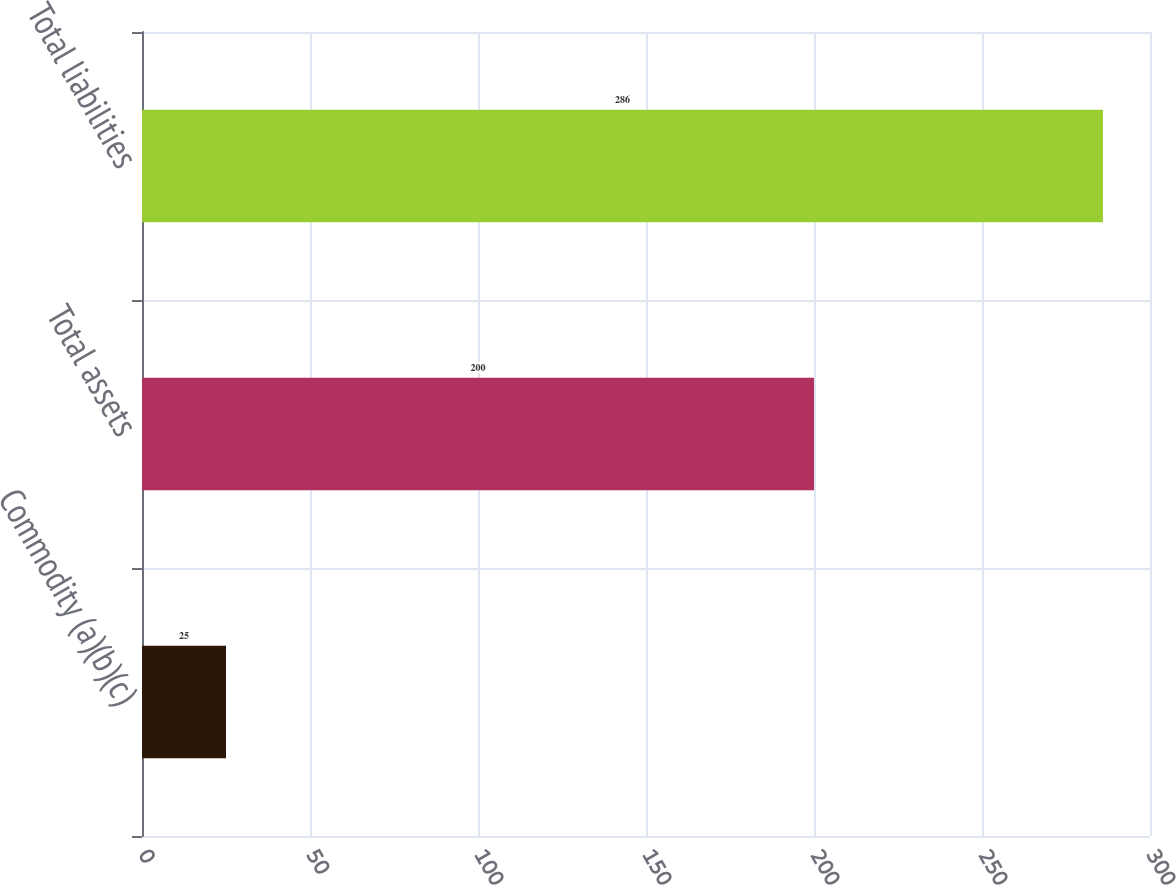Convert chart. <chart><loc_0><loc_0><loc_500><loc_500><bar_chart><fcel>Commodity (a)(b)(c)<fcel>Total assets<fcel>Total liabilities<nl><fcel>25<fcel>200<fcel>286<nl></chart> 